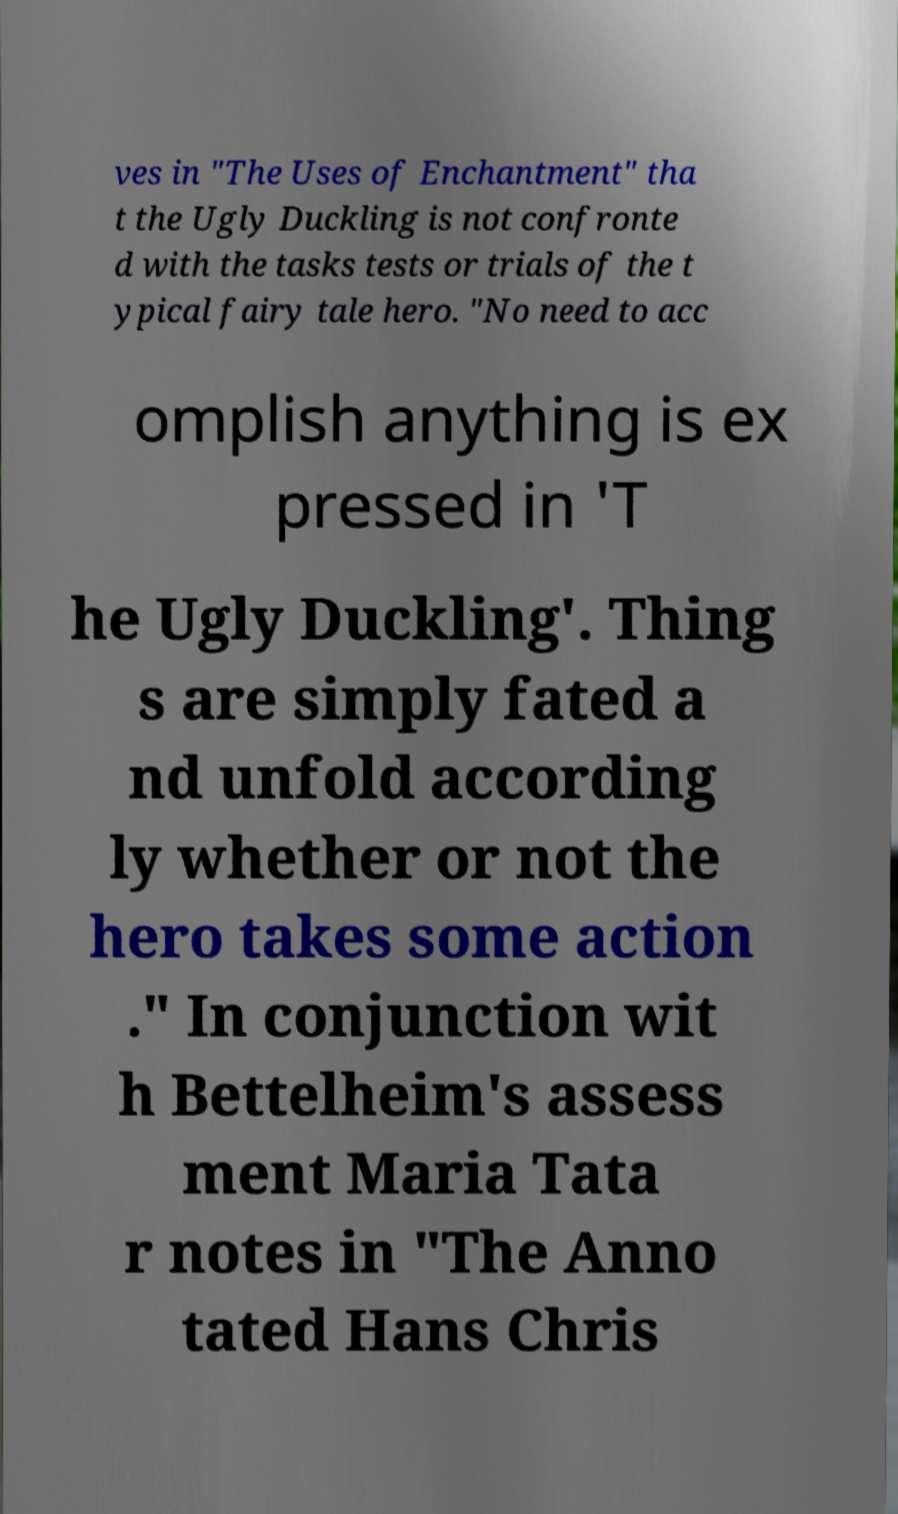Please identify and transcribe the text found in this image. ves in "The Uses of Enchantment" tha t the Ugly Duckling is not confronte d with the tasks tests or trials of the t ypical fairy tale hero. "No need to acc omplish anything is ex pressed in 'T he Ugly Duckling'. Thing s are simply fated a nd unfold according ly whether or not the hero takes some action ." In conjunction wit h Bettelheim's assess ment Maria Tata r notes in "The Anno tated Hans Chris 